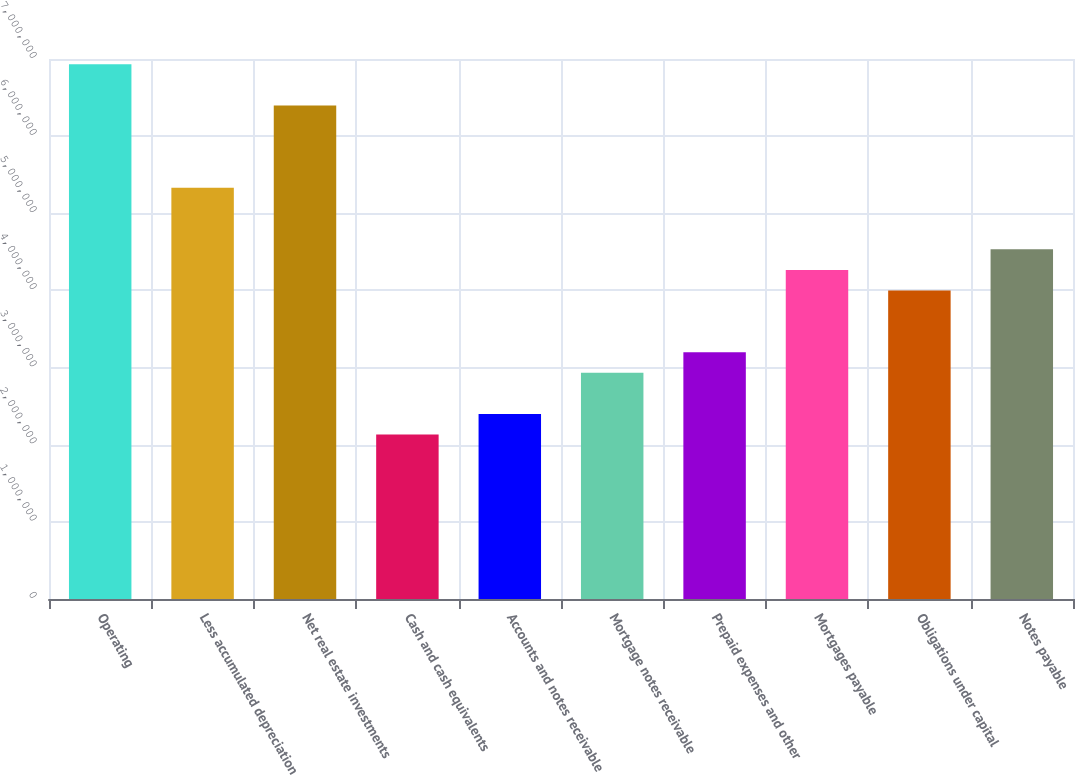<chart> <loc_0><loc_0><loc_500><loc_500><bar_chart><fcel>Operating<fcel>Less accumulated depreciation<fcel>Net real estate investments<fcel>Cash and cash equivalents<fcel>Accounts and notes receivable<fcel>Mortgage notes receivable<fcel>Prepaid expenses and other<fcel>Mortgages payable<fcel>Obligations under capital<fcel>Notes payable<nl><fcel>6.93146e+06<fcel>5.33202e+06<fcel>6.39831e+06<fcel>2.13313e+06<fcel>2.3997e+06<fcel>2.93285e+06<fcel>3.19942e+06<fcel>4.26572e+06<fcel>3.99915e+06<fcel>4.53229e+06<nl></chart> 